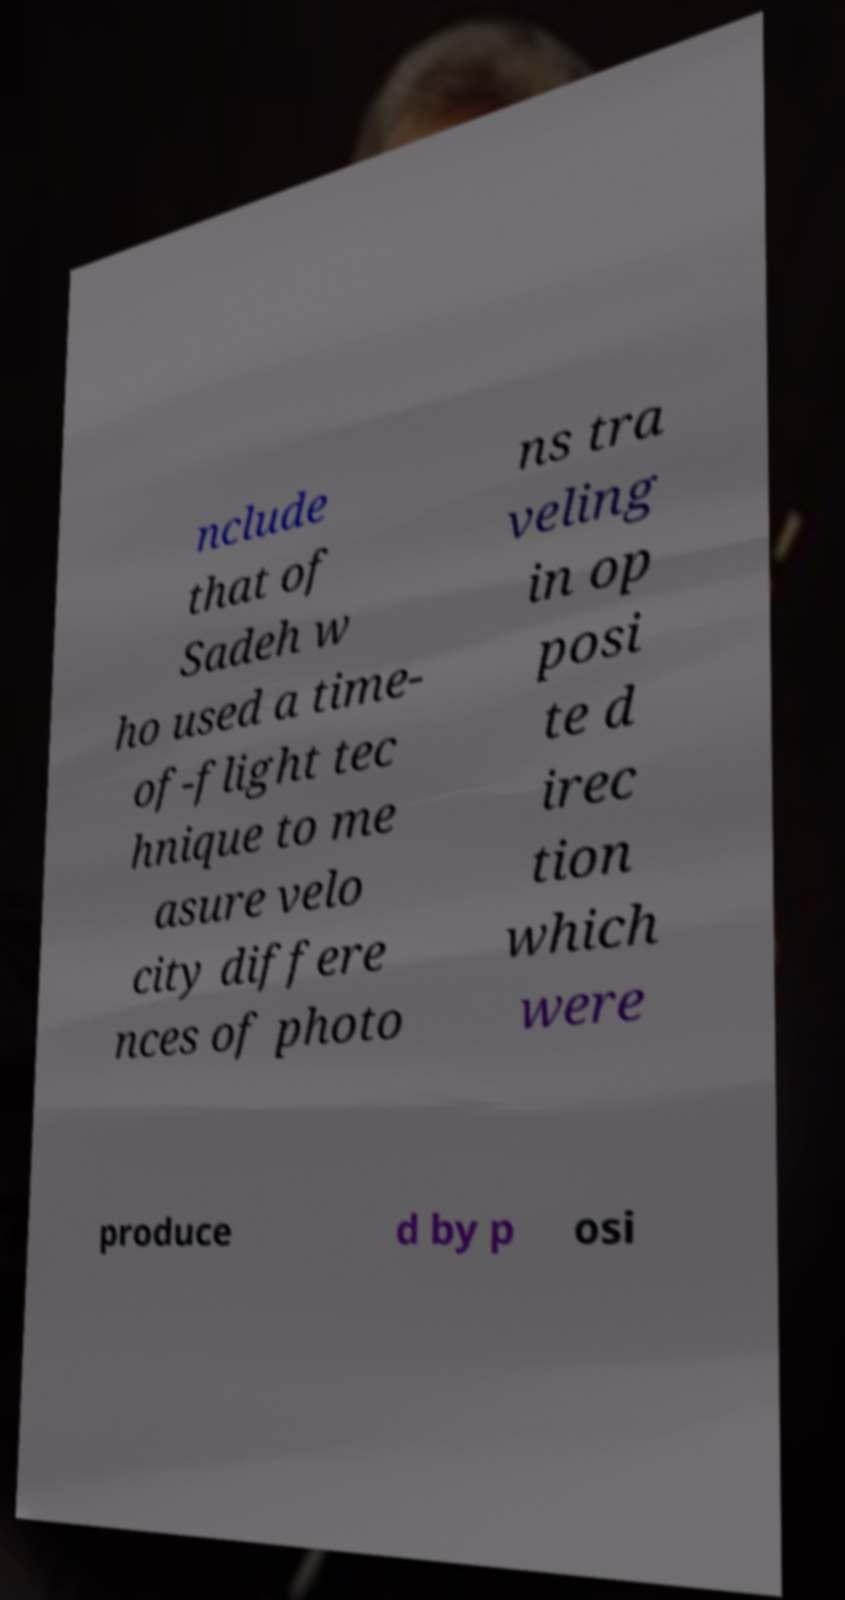Please identify and transcribe the text found in this image. nclude that of Sadeh w ho used a time- of-flight tec hnique to me asure velo city differe nces of photo ns tra veling in op posi te d irec tion which were produce d by p osi 